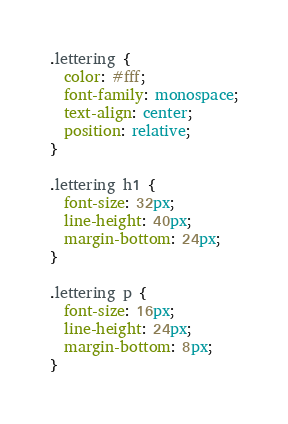<code> <loc_0><loc_0><loc_500><loc_500><_CSS_>.lettering {
  color: #fff;
  font-family: monospace;
  text-align: center;
  position: relative;
}

.lettering h1 {
  font-size: 32px;
  line-height: 40px;
  margin-bottom: 24px;
}

.lettering p {
  font-size: 16px;
  line-height: 24px;
  margin-bottom: 8px;
}
</code> 